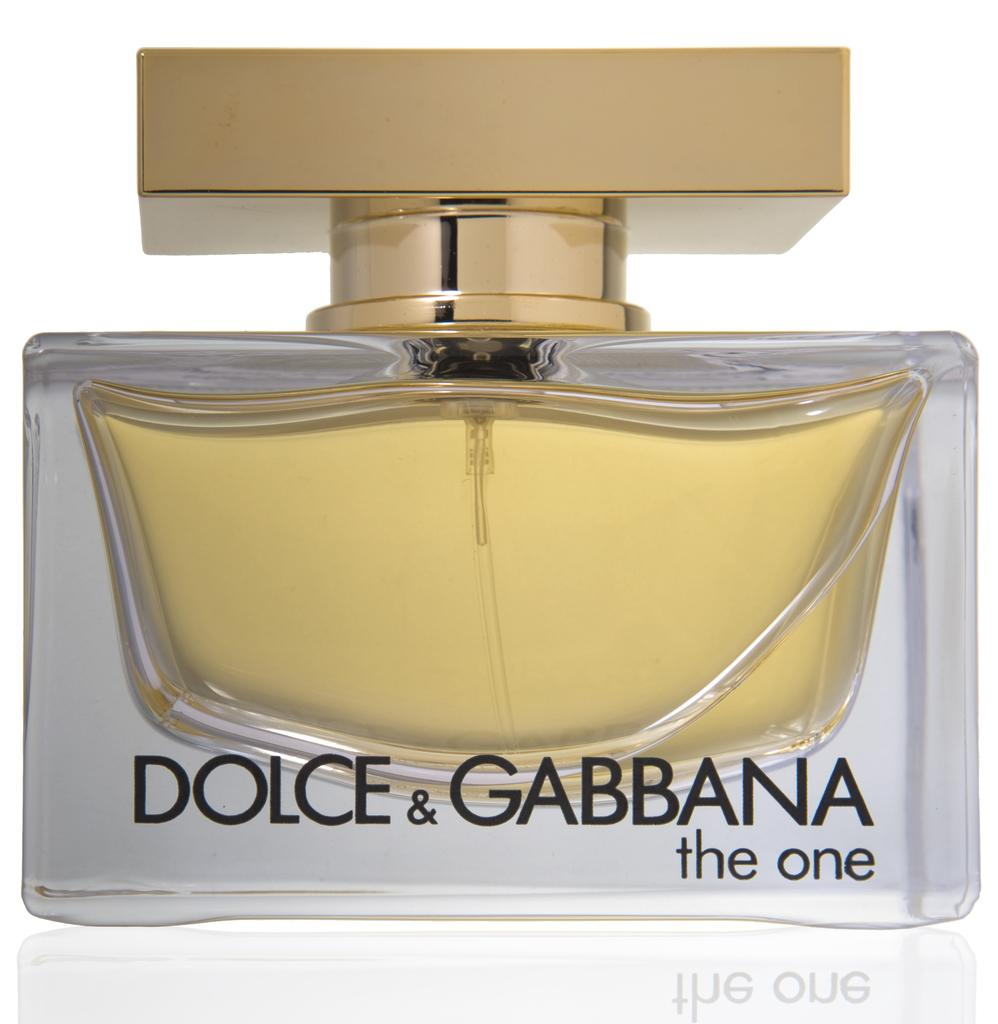Provide a one-sentence caption for the provided image. The One by Dolce & Gabbana comes in a glass bottle with a gold-toned cap. 